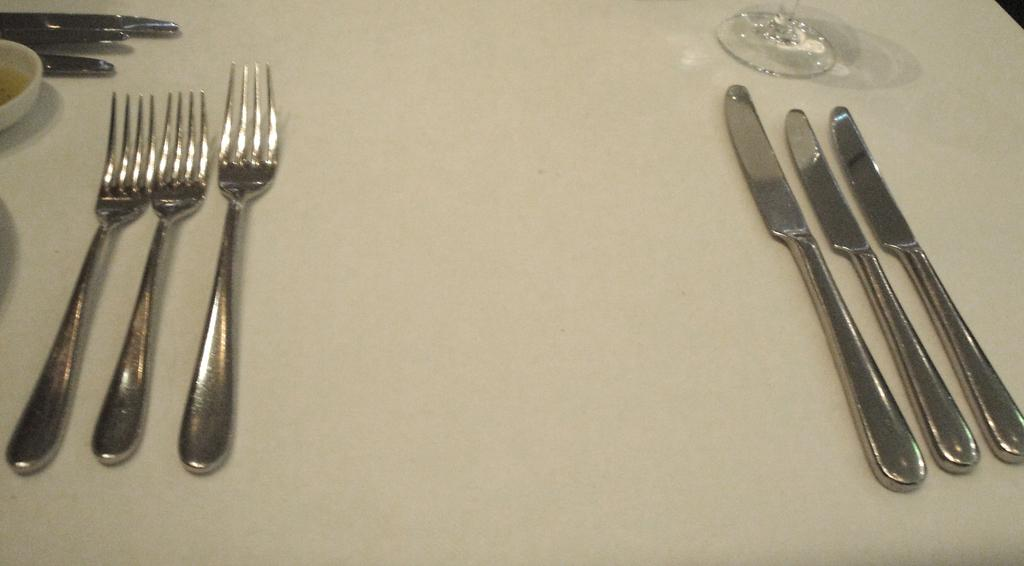What type of utensils can be seen in the image? There are forks and knives in the image. What type of tableware is present in the image? There are glasses in the image. What else can be found on the table in the image? There are other unspecified things on the table in the image. What type of smile can be seen on the quilt in the image? There is no quilt present in the image, and therefore no smile can be observed. 